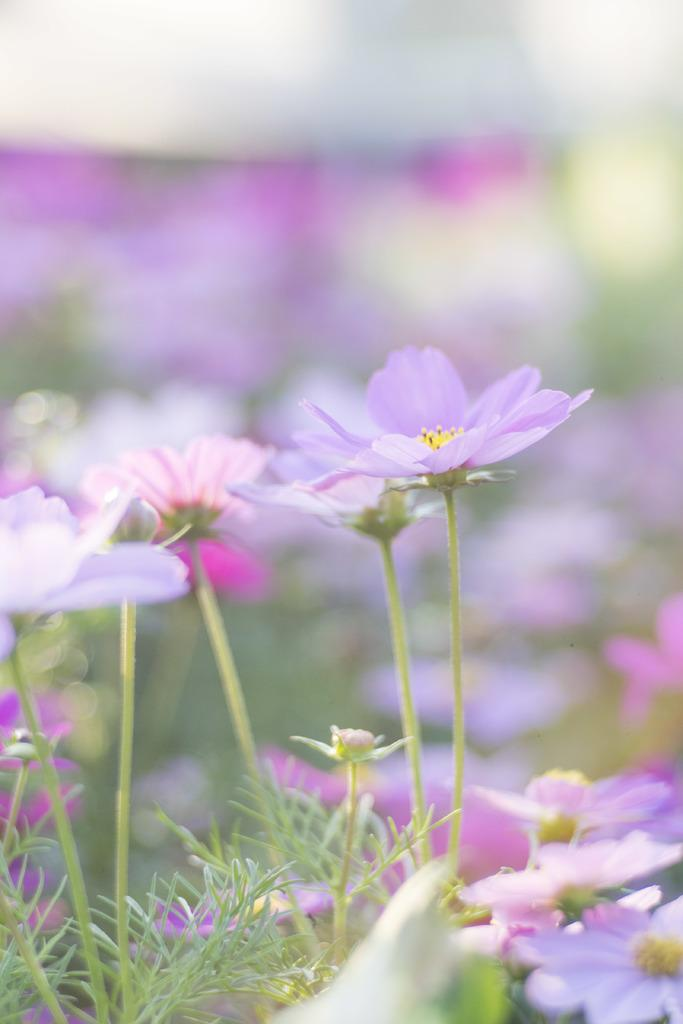What types of vegetation can be seen in the image? There are flowers and plants in the image. Can you describe the background of the image? The background of the image is blurred. What type of operation is being performed on the ice in the image? There is no ice or operation present in the image; it features flowers and plants with a blurred background. 